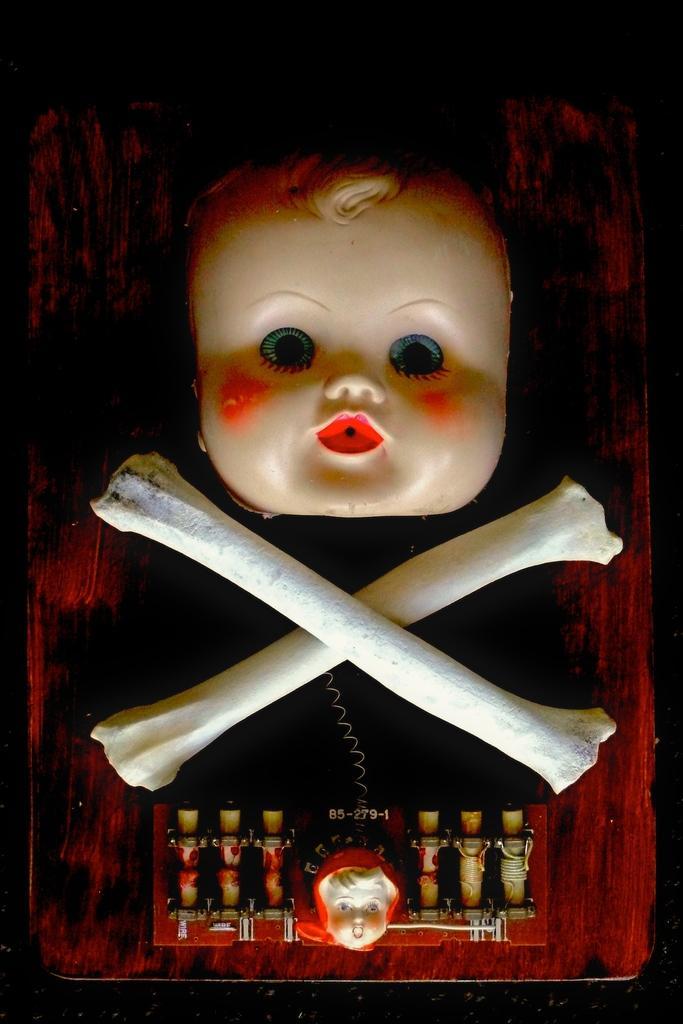In one or two sentences, can you explain what this image depicts? Here in this picture we can see a head of a toy and skeleton bones present on the table over there. 